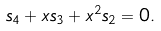Convert formula to latex. <formula><loc_0><loc_0><loc_500><loc_500>s _ { 4 } + x s _ { 3 } + x ^ { 2 } s _ { 2 } = 0 .</formula> 